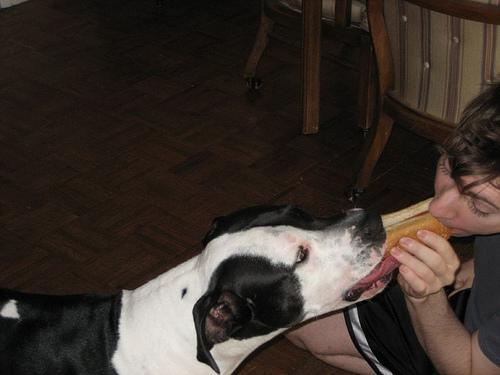Question: what is she doing?
Choices:
A. Smiling.
B. Talking.
C. Laughing.
D. Eating.
Answer with the letter. Answer: D Question: what is the person eating?
Choices:
A. Cake.
B. Sandwich.
C. Bread.
D. Food.
Answer with the letter. Answer: D Question: what animal is this?
Choices:
A. Dog.
B. Wolf.
C. Fox.
D. Coyote.
Answer with the letter. Answer: A Question: where is this scene?
Choices:
A. At work.
B. At home.
C. At school.
D. At practice.
Answer with the letter. Answer: B 